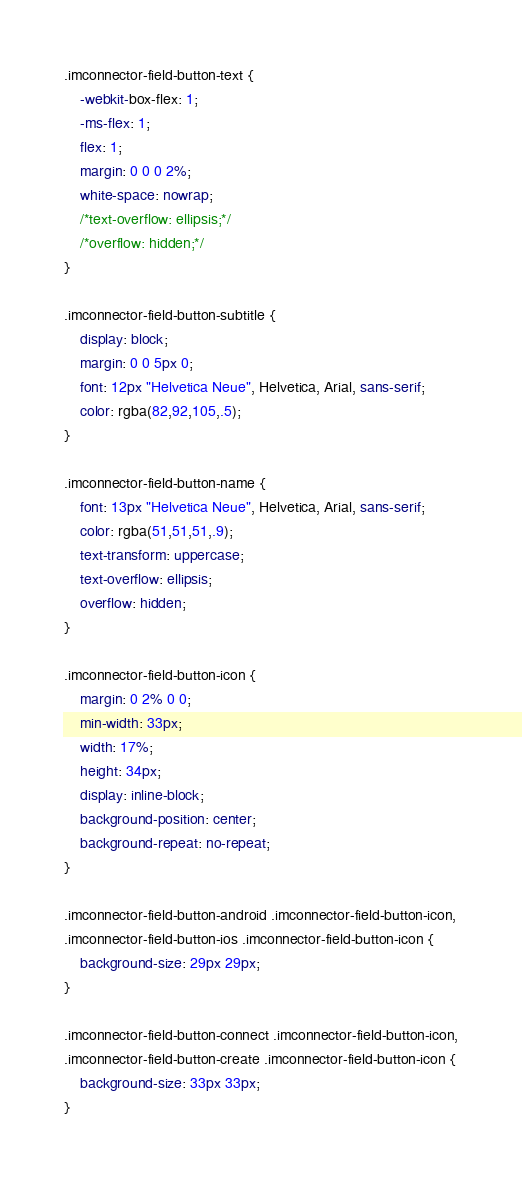Convert code to text. <code><loc_0><loc_0><loc_500><loc_500><_CSS_>.imconnector-field-button-text {
	-webkit-box-flex: 1;
	-ms-flex: 1;
	flex: 1;
	margin: 0 0 0 2%;
	white-space: nowrap;
	/*text-overflow: ellipsis;*/
	/*overflow: hidden;*/
}

.imconnector-field-button-subtitle {
	display: block;
	margin: 0 0 5px 0;
	font: 12px "Helvetica Neue", Helvetica, Arial, sans-serif;
	color: rgba(82,92,105,.5);
}

.imconnector-field-button-name {
	font: 13px "Helvetica Neue", Helvetica, Arial, sans-serif;
	color: rgba(51,51,51,.9);
	text-transform: uppercase;
	text-overflow: ellipsis;
	overflow: hidden;
}

.imconnector-field-button-icon {
	margin: 0 2% 0 0;
	min-width: 33px;
	width: 17%;
	height: 34px;
	display: inline-block;
	background-position: center;
	background-repeat: no-repeat;
}

.imconnector-field-button-android .imconnector-field-button-icon,
.imconnector-field-button-ios .imconnector-field-button-icon {
	background-size: 29px 29px;
}

.imconnector-field-button-connect .imconnector-field-button-icon,
.imconnector-field-button-create .imconnector-field-button-icon {
	background-size: 33px 33px;
}
</code> 